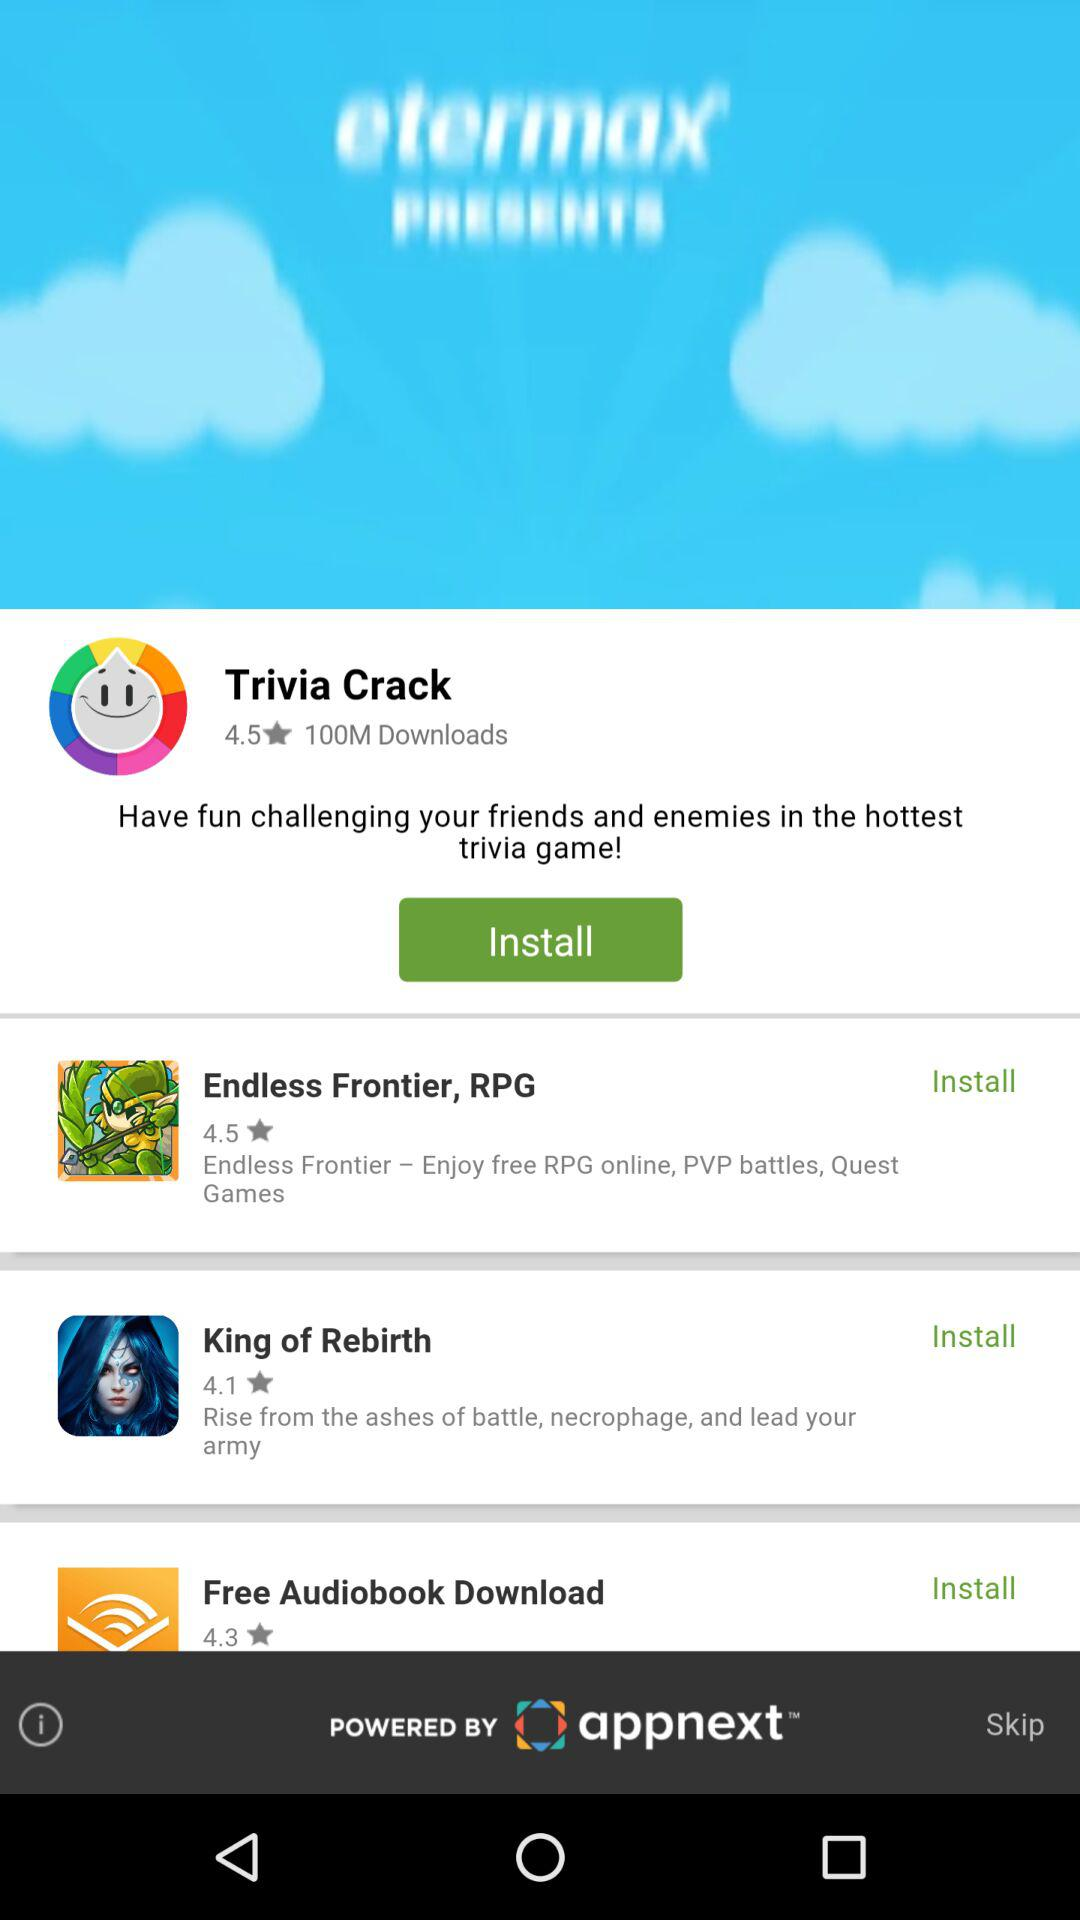What is the star rating of "Endless Frontier, RPG" application? The star rating of "Endless Frontier, RPG" is 4.5. 